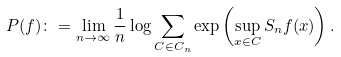Convert formula to latex. <formula><loc_0><loc_0><loc_500><loc_500>P ( f ) \colon = \lim _ { n \to \infty } \frac { 1 } { n } \log \sum _ { C \in C _ { n } } \exp \left ( \sup _ { x \in C } S _ { n } f ( x ) \right ) .</formula> 